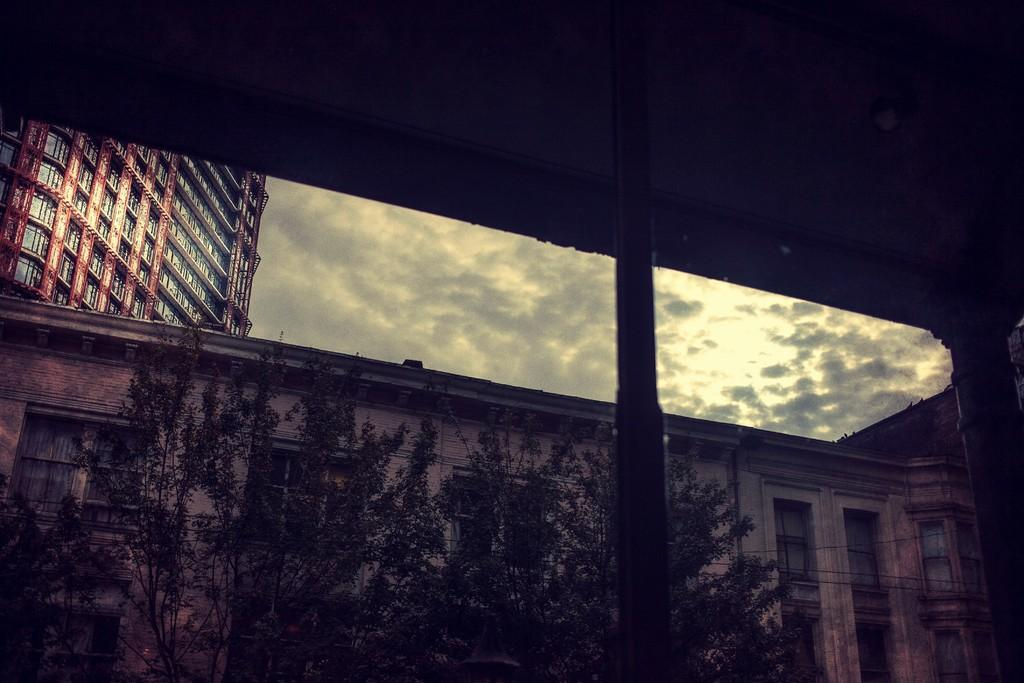What type of structures can be seen in the image? There are buildings in the image. What other natural elements are present in the image? There are trees in the image. What can be seen in the background of the image? The sky is visible in the background of the image. What is the condition of the sky in the image? Clouds are present in the sky. What role does the actor play in the image? There is no actor present in the image; it features buildings, trees, and a sky with clouds. How does the dust affect the visibility of the buildings in the image? There is no dust present in the image, so it does not affect the visibility of the buildings. 